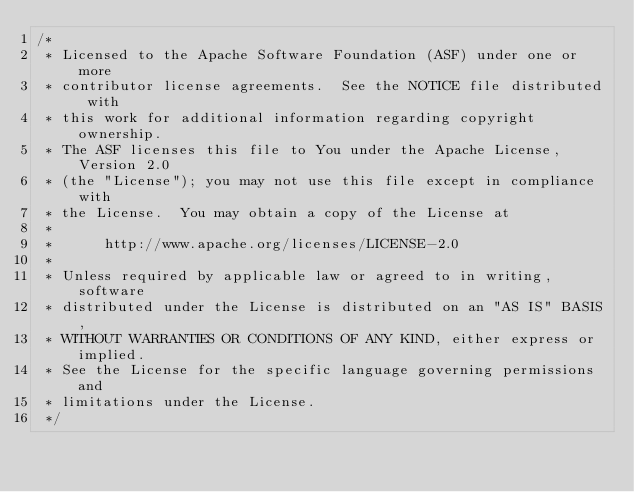Convert code to text. <code><loc_0><loc_0><loc_500><loc_500><_Java_>/*
 * Licensed to the Apache Software Foundation (ASF) under one or more
 * contributor license agreements.  See the NOTICE file distributed with
 * this work for additional information regarding copyright ownership.
 * The ASF licenses this file to You under the Apache License, Version 2.0
 * (the "License"); you may not use this file except in compliance with
 * the License.  You may obtain a copy of the License at
 *
 *      http://www.apache.org/licenses/LICENSE-2.0
 *
 * Unless required by applicable law or agreed to in writing, software
 * distributed under the License is distributed on an "AS IS" BASIS,
 * WITHOUT WARRANTIES OR CONDITIONS OF ANY KIND, either express or implied.
 * See the License for the specific language governing permissions and
 * limitations under the License.
 */</code> 